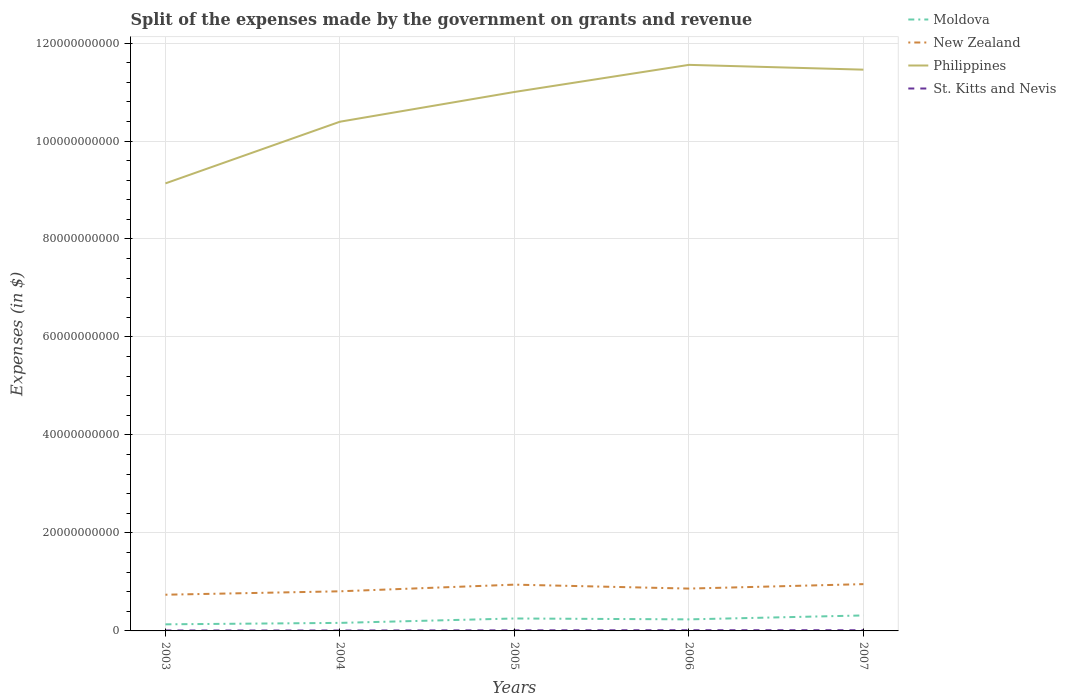How many different coloured lines are there?
Make the answer very short. 4. Does the line corresponding to Philippines intersect with the line corresponding to New Zealand?
Offer a terse response. No. Is the number of lines equal to the number of legend labels?
Your response must be concise. Yes. Across all years, what is the maximum expenses made by the government on grants and revenue in Moldova?
Your answer should be compact. 1.35e+09. What is the total expenses made by the government on grants and revenue in St. Kitts and Nevis in the graph?
Give a very brief answer. -3.42e+07. What is the difference between the highest and the second highest expenses made by the government on grants and revenue in Moldova?
Offer a very short reply. 1.81e+09. Is the expenses made by the government on grants and revenue in St. Kitts and Nevis strictly greater than the expenses made by the government on grants and revenue in New Zealand over the years?
Ensure brevity in your answer.  Yes. How many lines are there?
Offer a terse response. 4. Are the values on the major ticks of Y-axis written in scientific E-notation?
Your answer should be compact. No. How many legend labels are there?
Keep it short and to the point. 4. What is the title of the graph?
Make the answer very short. Split of the expenses made by the government on grants and revenue. Does "Venezuela" appear as one of the legend labels in the graph?
Make the answer very short. No. What is the label or title of the X-axis?
Offer a terse response. Years. What is the label or title of the Y-axis?
Offer a very short reply. Expenses (in $). What is the Expenses (in $) of Moldova in 2003?
Keep it short and to the point. 1.35e+09. What is the Expenses (in $) in New Zealand in 2003?
Offer a terse response. 7.39e+09. What is the Expenses (in $) in Philippines in 2003?
Your response must be concise. 9.14e+1. What is the Expenses (in $) of St. Kitts and Nevis in 2003?
Your answer should be compact. 9.36e+07. What is the Expenses (in $) in Moldova in 2004?
Your answer should be compact. 1.64e+09. What is the Expenses (in $) in New Zealand in 2004?
Offer a terse response. 8.09e+09. What is the Expenses (in $) of Philippines in 2004?
Ensure brevity in your answer.  1.04e+11. What is the Expenses (in $) of St. Kitts and Nevis in 2004?
Ensure brevity in your answer.  8.76e+07. What is the Expenses (in $) in Moldova in 2005?
Keep it short and to the point. 2.54e+09. What is the Expenses (in $) in New Zealand in 2005?
Give a very brief answer. 9.45e+09. What is the Expenses (in $) in Philippines in 2005?
Make the answer very short. 1.10e+11. What is the Expenses (in $) in St. Kitts and Nevis in 2005?
Your answer should be very brief. 1.22e+08. What is the Expenses (in $) in Moldova in 2006?
Offer a very short reply. 2.36e+09. What is the Expenses (in $) in New Zealand in 2006?
Keep it short and to the point. 8.64e+09. What is the Expenses (in $) of Philippines in 2006?
Offer a terse response. 1.16e+11. What is the Expenses (in $) of St. Kitts and Nevis in 2006?
Provide a succinct answer. 1.44e+08. What is the Expenses (in $) in Moldova in 2007?
Your answer should be very brief. 3.16e+09. What is the Expenses (in $) of New Zealand in 2007?
Offer a very short reply. 9.55e+09. What is the Expenses (in $) of Philippines in 2007?
Your response must be concise. 1.15e+11. What is the Expenses (in $) in St. Kitts and Nevis in 2007?
Make the answer very short. 1.45e+08. Across all years, what is the maximum Expenses (in $) in Moldova?
Your response must be concise. 3.16e+09. Across all years, what is the maximum Expenses (in $) in New Zealand?
Your answer should be compact. 9.55e+09. Across all years, what is the maximum Expenses (in $) of Philippines?
Keep it short and to the point. 1.16e+11. Across all years, what is the maximum Expenses (in $) of St. Kitts and Nevis?
Keep it short and to the point. 1.45e+08. Across all years, what is the minimum Expenses (in $) of Moldova?
Ensure brevity in your answer.  1.35e+09. Across all years, what is the minimum Expenses (in $) in New Zealand?
Provide a succinct answer. 7.39e+09. Across all years, what is the minimum Expenses (in $) in Philippines?
Your answer should be very brief. 9.14e+1. Across all years, what is the minimum Expenses (in $) in St. Kitts and Nevis?
Ensure brevity in your answer.  8.76e+07. What is the total Expenses (in $) of Moldova in the graph?
Offer a very short reply. 1.10e+1. What is the total Expenses (in $) in New Zealand in the graph?
Offer a terse response. 4.31e+1. What is the total Expenses (in $) in Philippines in the graph?
Your answer should be compact. 5.35e+11. What is the total Expenses (in $) of St. Kitts and Nevis in the graph?
Your answer should be compact. 5.92e+08. What is the difference between the Expenses (in $) of Moldova in 2003 and that in 2004?
Offer a terse response. -2.94e+08. What is the difference between the Expenses (in $) in New Zealand in 2003 and that in 2004?
Your answer should be compact. -6.97e+08. What is the difference between the Expenses (in $) of Philippines in 2003 and that in 2004?
Keep it short and to the point. -1.26e+1. What is the difference between the Expenses (in $) in St. Kitts and Nevis in 2003 and that in 2004?
Provide a succinct answer. 6.00e+06. What is the difference between the Expenses (in $) in Moldova in 2003 and that in 2005?
Offer a terse response. -1.19e+09. What is the difference between the Expenses (in $) in New Zealand in 2003 and that in 2005?
Your answer should be compact. -2.06e+09. What is the difference between the Expenses (in $) in Philippines in 2003 and that in 2005?
Keep it short and to the point. -1.87e+1. What is the difference between the Expenses (in $) of St. Kitts and Nevis in 2003 and that in 2005?
Your response must be concise. -2.82e+07. What is the difference between the Expenses (in $) of Moldova in 2003 and that in 2006?
Offer a terse response. -1.01e+09. What is the difference between the Expenses (in $) of New Zealand in 2003 and that in 2006?
Provide a succinct answer. -1.25e+09. What is the difference between the Expenses (in $) of Philippines in 2003 and that in 2006?
Provide a succinct answer. -2.42e+1. What is the difference between the Expenses (in $) of St. Kitts and Nevis in 2003 and that in 2006?
Ensure brevity in your answer.  -5.08e+07. What is the difference between the Expenses (in $) of Moldova in 2003 and that in 2007?
Your answer should be compact. -1.81e+09. What is the difference between the Expenses (in $) in New Zealand in 2003 and that in 2007?
Make the answer very short. -2.16e+09. What is the difference between the Expenses (in $) in Philippines in 2003 and that in 2007?
Keep it short and to the point. -2.32e+1. What is the difference between the Expenses (in $) of St. Kitts and Nevis in 2003 and that in 2007?
Give a very brief answer. -5.14e+07. What is the difference between the Expenses (in $) of Moldova in 2004 and that in 2005?
Make the answer very short. -9.00e+08. What is the difference between the Expenses (in $) of New Zealand in 2004 and that in 2005?
Make the answer very short. -1.36e+09. What is the difference between the Expenses (in $) of Philippines in 2004 and that in 2005?
Make the answer very short. -6.07e+09. What is the difference between the Expenses (in $) of St. Kitts and Nevis in 2004 and that in 2005?
Keep it short and to the point. -3.42e+07. What is the difference between the Expenses (in $) in Moldova in 2004 and that in 2006?
Offer a very short reply. -7.19e+08. What is the difference between the Expenses (in $) in New Zealand in 2004 and that in 2006?
Give a very brief answer. -5.56e+08. What is the difference between the Expenses (in $) in Philippines in 2004 and that in 2006?
Ensure brevity in your answer.  -1.16e+1. What is the difference between the Expenses (in $) in St. Kitts and Nevis in 2004 and that in 2006?
Your response must be concise. -5.68e+07. What is the difference between the Expenses (in $) in Moldova in 2004 and that in 2007?
Provide a short and direct response. -1.52e+09. What is the difference between the Expenses (in $) in New Zealand in 2004 and that in 2007?
Offer a terse response. -1.46e+09. What is the difference between the Expenses (in $) in Philippines in 2004 and that in 2007?
Offer a very short reply. -1.06e+1. What is the difference between the Expenses (in $) of St. Kitts and Nevis in 2004 and that in 2007?
Your response must be concise. -5.74e+07. What is the difference between the Expenses (in $) of Moldova in 2005 and that in 2006?
Your answer should be very brief. 1.80e+08. What is the difference between the Expenses (in $) in New Zealand in 2005 and that in 2006?
Give a very brief answer. 8.05e+08. What is the difference between the Expenses (in $) of Philippines in 2005 and that in 2006?
Make the answer very short. -5.54e+09. What is the difference between the Expenses (in $) in St. Kitts and Nevis in 2005 and that in 2006?
Give a very brief answer. -2.26e+07. What is the difference between the Expenses (in $) in Moldova in 2005 and that in 2007?
Ensure brevity in your answer.  -6.21e+08. What is the difference between the Expenses (in $) of New Zealand in 2005 and that in 2007?
Make the answer very short. -1.03e+08. What is the difference between the Expenses (in $) of Philippines in 2005 and that in 2007?
Provide a succinct answer. -4.56e+09. What is the difference between the Expenses (in $) of St. Kitts and Nevis in 2005 and that in 2007?
Your answer should be compact. -2.32e+07. What is the difference between the Expenses (in $) in Moldova in 2006 and that in 2007?
Offer a terse response. -8.02e+08. What is the difference between the Expenses (in $) in New Zealand in 2006 and that in 2007?
Offer a very short reply. -9.08e+08. What is the difference between the Expenses (in $) of Philippines in 2006 and that in 2007?
Offer a very short reply. 9.80e+08. What is the difference between the Expenses (in $) in St. Kitts and Nevis in 2006 and that in 2007?
Your answer should be compact. -6.00e+05. What is the difference between the Expenses (in $) in Moldova in 2003 and the Expenses (in $) in New Zealand in 2004?
Ensure brevity in your answer.  -6.74e+09. What is the difference between the Expenses (in $) of Moldova in 2003 and the Expenses (in $) of Philippines in 2004?
Offer a terse response. -1.03e+11. What is the difference between the Expenses (in $) of Moldova in 2003 and the Expenses (in $) of St. Kitts and Nevis in 2004?
Your answer should be very brief. 1.26e+09. What is the difference between the Expenses (in $) in New Zealand in 2003 and the Expenses (in $) in Philippines in 2004?
Provide a succinct answer. -9.65e+1. What is the difference between the Expenses (in $) in New Zealand in 2003 and the Expenses (in $) in St. Kitts and Nevis in 2004?
Provide a succinct answer. 7.30e+09. What is the difference between the Expenses (in $) in Philippines in 2003 and the Expenses (in $) in St. Kitts and Nevis in 2004?
Ensure brevity in your answer.  9.13e+1. What is the difference between the Expenses (in $) of Moldova in 2003 and the Expenses (in $) of New Zealand in 2005?
Provide a succinct answer. -8.10e+09. What is the difference between the Expenses (in $) of Moldova in 2003 and the Expenses (in $) of Philippines in 2005?
Give a very brief answer. -1.09e+11. What is the difference between the Expenses (in $) of Moldova in 2003 and the Expenses (in $) of St. Kitts and Nevis in 2005?
Make the answer very short. 1.22e+09. What is the difference between the Expenses (in $) of New Zealand in 2003 and the Expenses (in $) of Philippines in 2005?
Make the answer very short. -1.03e+11. What is the difference between the Expenses (in $) of New Zealand in 2003 and the Expenses (in $) of St. Kitts and Nevis in 2005?
Offer a very short reply. 7.27e+09. What is the difference between the Expenses (in $) of Philippines in 2003 and the Expenses (in $) of St. Kitts and Nevis in 2005?
Give a very brief answer. 9.12e+1. What is the difference between the Expenses (in $) of Moldova in 2003 and the Expenses (in $) of New Zealand in 2006?
Your response must be concise. -7.30e+09. What is the difference between the Expenses (in $) in Moldova in 2003 and the Expenses (in $) in Philippines in 2006?
Give a very brief answer. -1.14e+11. What is the difference between the Expenses (in $) in Moldova in 2003 and the Expenses (in $) in St. Kitts and Nevis in 2006?
Your answer should be very brief. 1.20e+09. What is the difference between the Expenses (in $) in New Zealand in 2003 and the Expenses (in $) in Philippines in 2006?
Provide a succinct answer. -1.08e+11. What is the difference between the Expenses (in $) in New Zealand in 2003 and the Expenses (in $) in St. Kitts and Nevis in 2006?
Offer a terse response. 7.25e+09. What is the difference between the Expenses (in $) in Philippines in 2003 and the Expenses (in $) in St. Kitts and Nevis in 2006?
Make the answer very short. 9.12e+1. What is the difference between the Expenses (in $) of Moldova in 2003 and the Expenses (in $) of New Zealand in 2007?
Make the answer very short. -8.20e+09. What is the difference between the Expenses (in $) in Moldova in 2003 and the Expenses (in $) in Philippines in 2007?
Offer a terse response. -1.13e+11. What is the difference between the Expenses (in $) of Moldova in 2003 and the Expenses (in $) of St. Kitts and Nevis in 2007?
Make the answer very short. 1.20e+09. What is the difference between the Expenses (in $) in New Zealand in 2003 and the Expenses (in $) in Philippines in 2007?
Offer a very short reply. -1.07e+11. What is the difference between the Expenses (in $) in New Zealand in 2003 and the Expenses (in $) in St. Kitts and Nevis in 2007?
Your response must be concise. 7.25e+09. What is the difference between the Expenses (in $) of Philippines in 2003 and the Expenses (in $) of St. Kitts and Nevis in 2007?
Your answer should be compact. 9.12e+1. What is the difference between the Expenses (in $) of Moldova in 2004 and the Expenses (in $) of New Zealand in 2005?
Provide a succinct answer. -7.81e+09. What is the difference between the Expenses (in $) of Moldova in 2004 and the Expenses (in $) of Philippines in 2005?
Your answer should be very brief. -1.08e+11. What is the difference between the Expenses (in $) in Moldova in 2004 and the Expenses (in $) in St. Kitts and Nevis in 2005?
Make the answer very short. 1.52e+09. What is the difference between the Expenses (in $) of New Zealand in 2004 and the Expenses (in $) of Philippines in 2005?
Keep it short and to the point. -1.02e+11. What is the difference between the Expenses (in $) in New Zealand in 2004 and the Expenses (in $) in St. Kitts and Nevis in 2005?
Your answer should be very brief. 7.97e+09. What is the difference between the Expenses (in $) in Philippines in 2004 and the Expenses (in $) in St. Kitts and Nevis in 2005?
Offer a very short reply. 1.04e+11. What is the difference between the Expenses (in $) of Moldova in 2004 and the Expenses (in $) of New Zealand in 2006?
Provide a short and direct response. -7.00e+09. What is the difference between the Expenses (in $) of Moldova in 2004 and the Expenses (in $) of Philippines in 2006?
Keep it short and to the point. -1.14e+11. What is the difference between the Expenses (in $) of Moldova in 2004 and the Expenses (in $) of St. Kitts and Nevis in 2006?
Offer a terse response. 1.50e+09. What is the difference between the Expenses (in $) of New Zealand in 2004 and the Expenses (in $) of Philippines in 2006?
Make the answer very short. -1.07e+11. What is the difference between the Expenses (in $) in New Zealand in 2004 and the Expenses (in $) in St. Kitts and Nevis in 2006?
Your response must be concise. 7.94e+09. What is the difference between the Expenses (in $) in Philippines in 2004 and the Expenses (in $) in St. Kitts and Nevis in 2006?
Provide a succinct answer. 1.04e+11. What is the difference between the Expenses (in $) in Moldova in 2004 and the Expenses (in $) in New Zealand in 2007?
Offer a very short reply. -7.91e+09. What is the difference between the Expenses (in $) in Moldova in 2004 and the Expenses (in $) in Philippines in 2007?
Your response must be concise. -1.13e+11. What is the difference between the Expenses (in $) in Moldova in 2004 and the Expenses (in $) in St. Kitts and Nevis in 2007?
Your response must be concise. 1.49e+09. What is the difference between the Expenses (in $) of New Zealand in 2004 and the Expenses (in $) of Philippines in 2007?
Your answer should be compact. -1.06e+11. What is the difference between the Expenses (in $) of New Zealand in 2004 and the Expenses (in $) of St. Kitts and Nevis in 2007?
Ensure brevity in your answer.  7.94e+09. What is the difference between the Expenses (in $) of Philippines in 2004 and the Expenses (in $) of St. Kitts and Nevis in 2007?
Provide a succinct answer. 1.04e+11. What is the difference between the Expenses (in $) of Moldova in 2005 and the Expenses (in $) of New Zealand in 2006?
Offer a terse response. -6.10e+09. What is the difference between the Expenses (in $) of Moldova in 2005 and the Expenses (in $) of Philippines in 2006?
Give a very brief answer. -1.13e+11. What is the difference between the Expenses (in $) in Moldova in 2005 and the Expenses (in $) in St. Kitts and Nevis in 2006?
Your answer should be compact. 2.39e+09. What is the difference between the Expenses (in $) in New Zealand in 2005 and the Expenses (in $) in Philippines in 2006?
Your answer should be very brief. -1.06e+11. What is the difference between the Expenses (in $) of New Zealand in 2005 and the Expenses (in $) of St. Kitts and Nevis in 2006?
Provide a succinct answer. 9.30e+09. What is the difference between the Expenses (in $) of Philippines in 2005 and the Expenses (in $) of St. Kitts and Nevis in 2006?
Offer a terse response. 1.10e+11. What is the difference between the Expenses (in $) of Moldova in 2005 and the Expenses (in $) of New Zealand in 2007?
Offer a terse response. -7.01e+09. What is the difference between the Expenses (in $) in Moldova in 2005 and the Expenses (in $) in Philippines in 2007?
Your response must be concise. -1.12e+11. What is the difference between the Expenses (in $) of Moldova in 2005 and the Expenses (in $) of St. Kitts and Nevis in 2007?
Provide a short and direct response. 2.39e+09. What is the difference between the Expenses (in $) in New Zealand in 2005 and the Expenses (in $) in Philippines in 2007?
Provide a short and direct response. -1.05e+11. What is the difference between the Expenses (in $) in New Zealand in 2005 and the Expenses (in $) in St. Kitts and Nevis in 2007?
Provide a short and direct response. 9.30e+09. What is the difference between the Expenses (in $) in Philippines in 2005 and the Expenses (in $) in St. Kitts and Nevis in 2007?
Provide a succinct answer. 1.10e+11. What is the difference between the Expenses (in $) of Moldova in 2006 and the Expenses (in $) of New Zealand in 2007?
Your answer should be very brief. -7.19e+09. What is the difference between the Expenses (in $) in Moldova in 2006 and the Expenses (in $) in Philippines in 2007?
Offer a terse response. -1.12e+11. What is the difference between the Expenses (in $) of Moldova in 2006 and the Expenses (in $) of St. Kitts and Nevis in 2007?
Make the answer very short. 2.21e+09. What is the difference between the Expenses (in $) in New Zealand in 2006 and the Expenses (in $) in Philippines in 2007?
Ensure brevity in your answer.  -1.06e+11. What is the difference between the Expenses (in $) in New Zealand in 2006 and the Expenses (in $) in St. Kitts and Nevis in 2007?
Your answer should be very brief. 8.50e+09. What is the difference between the Expenses (in $) of Philippines in 2006 and the Expenses (in $) of St. Kitts and Nevis in 2007?
Give a very brief answer. 1.15e+11. What is the average Expenses (in $) of Moldova per year?
Make the answer very short. 2.21e+09. What is the average Expenses (in $) in New Zealand per year?
Your answer should be very brief. 8.62e+09. What is the average Expenses (in $) of Philippines per year?
Offer a very short reply. 1.07e+11. What is the average Expenses (in $) in St. Kitts and Nevis per year?
Make the answer very short. 1.18e+08. In the year 2003, what is the difference between the Expenses (in $) of Moldova and Expenses (in $) of New Zealand?
Make the answer very short. -6.04e+09. In the year 2003, what is the difference between the Expenses (in $) in Moldova and Expenses (in $) in Philippines?
Give a very brief answer. -9.00e+1. In the year 2003, what is the difference between the Expenses (in $) of Moldova and Expenses (in $) of St. Kitts and Nevis?
Ensure brevity in your answer.  1.25e+09. In the year 2003, what is the difference between the Expenses (in $) of New Zealand and Expenses (in $) of Philippines?
Ensure brevity in your answer.  -8.40e+1. In the year 2003, what is the difference between the Expenses (in $) in New Zealand and Expenses (in $) in St. Kitts and Nevis?
Your answer should be very brief. 7.30e+09. In the year 2003, what is the difference between the Expenses (in $) in Philippines and Expenses (in $) in St. Kitts and Nevis?
Your answer should be compact. 9.13e+1. In the year 2004, what is the difference between the Expenses (in $) of Moldova and Expenses (in $) of New Zealand?
Provide a succinct answer. -6.45e+09. In the year 2004, what is the difference between the Expenses (in $) of Moldova and Expenses (in $) of Philippines?
Keep it short and to the point. -1.02e+11. In the year 2004, what is the difference between the Expenses (in $) in Moldova and Expenses (in $) in St. Kitts and Nevis?
Ensure brevity in your answer.  1.55e+09. In the year 2004, what is the difference between the Expenses (in $) in New Zealand and Expenses (in $) in Philippines?
Your answer should be compact. -9.59e+1. In the year 2004, what is the difference between the Expenses (in $) in New Zealand and Expenses (in $) in St. Kitts and Nevis?
Offer a very short reply. 8.00e+09. In the year 2004, what is the difference between the Expenses (in $) in Philippines and Expenses (in $) in St. Kitts and Nevis?
Your answer should be very brief. 1.04e+11. In the year 2005, what is the difference between the Expenses (in $) in Moldova and Expenses (in $) in New Zealand?
Ensure brevity in your answer.  -6.91e+09. In the year 2005, what is the difference between the Expenses (in $) in Moldova and Expenses (in $) in Philippines?
Offer a very short reply. -1.07e+11. In the year 2005, what is the difference between the Expenses (in $) of Moldova and Expenses (in $) of St. Kitts and Nevis?
Offer a terse response. 2.42e+09. In the year 2005, what is the difference between the Expenses (in $) in New Zealand and Expenses (in $) in Philippines?
Your response must be concise. -1.01e+11. In the year 2005, what is the difference between the Expenses (in $) of New Zealand and Expenses (in $) of St. Kitts and Nevis?
Offer a terse response. 9.33e+09. In the year 2005, what is the difference between the Expenses (in $) of Philippines and Expenses (in $) of St. Kitts and Nevis?
Keep it short and to the point. 1.10e+11. In the year 2006, what is the difference between the Expenses (in $) in Moldova and Expenses (in $) in New Zealand?
Offer a terse response. -6.28e+09. In the year 2006, what is the difference between the Expenses (in $) in Moldova and Expenses (in $) in Philippines?
Offer a very short reply. -1.13e+11. In the year 2006, what is the difference between the Expenses (in $) of Moldova and Expenses (in $) of St. Kitts and Nevis?
Your answer should be very brief. 2.21e+09. In the year 2006, what is the difference between the Expenses (in $) in New Zealand and Expenses (in $) in Philippines?
Ensure brevity in your answer.  -1.07e+11. In the year 2006, what is the difference between the Expenses (in $) of New Zealand and Expenses (in $) of St. Kitts and Nevis?
Your answer should be very brief. 8.50e+09. In the year 2006, what is the difference between the Expenses (in $) of Philippines and Expenses (in $) of St. Kitts and Nevis?
Offer a very short reply. 1.15e+11. In the year 2007, what is the difference between the Expenses (in $) of Moldova and Expenses (in $) of New Zealand?
Ensure brevity in your answer.  -6.39e+09. In the year 2007, what is the difference between the Expenses (in $) in Moldova and Expenses (in $) in Philippines?
Give a very brief answer. -1.11e+11. In the year 2007, what is the difference between the Expenses (in $) of Moldova and Expenses (in $) of St. Kitts and Nevis?
Your response must be concise. 3.02e+09. In the year 2007, what is the difference between the Expenses (in $) in New Zealand and Expenses (in $) in Philippines?
Provide a short and direct response. -1.05e+11. In the year 2007, what is the difference between the Expenses (in $) in New Zealand and Expenses (in $) in St. Kitts and Nevis?
Offer a very short reply. 9.41e+09. In the year 2007, what is the difference between the Expenses (in $) in Philippines and Expenses (in $) in St. Kitts and Nevis?
Your answer should be very brief. 1.14e+11. What is the ratio of the Expenses (in $) in Moldova in 2003 to that in 2004?
Provide a short and direct response. 0.82. What is the ratio of the Expenses (in $) of New Zealand in 2003 to that in 2004?
Make the answer very short. 0.91. What is the ratio of the Expenses (in $) of Philippines in 2003 to that in 2004?
Your response must be concise. 0.88. What is the ratio of the Expenses (in $) in St. Kitts and Nevis in 2003 to that in 2004?
Your response must be concise. 1.07. What is the ratio of the Expenses (in $) of Moldova in 2003 to that in 2005?
Offer a very short reply. 0.53. What is the ratio of the Expenses (in $) in New Zealand in 2003 to that in 2005?
Give a very brief answer. 0.78. What is the ratio of the Expenses (in $) in Philippines in 2003 to that in 2005?
Provide a succinct answer. 0.83. What is the ratio of the Expenses (in $) of St. Kitts and Nevis in 2003 to that in 2005?
Offer a very short reply. 0.77. What is the ratio of the Expenses (in $) in Moldova in 2003 to that in 2006?
Give a very brief answer. 0.57. What is the ratio of the Expenses (in $) in New Zealand in 2003 to that in 2006?
Make the answer very short. 0.86. What is the ratio of the Expenses (in $) in Philippines in 2003 to that in 2006?
Make the answer very short. 0.79. What is the ratio of the Expenses (in $) of St. Kitts and Nevis in 2003 to that in 2006?
Make the answer very short. 0.65. What is the ratio of the Expenses (in $) of Moldova in 2003 to that in 2007?
Give a very brief answer. 0.43. What is the ratio of the Expenses (in $) in New Zealand in 2003 to that in 2007?
Provide a short and direct response. 0.77. What is the ratio of the Expenses (in $) of Philippines in 2003 to that in 2007?
Keep it short and to the point. 0.8. What is the ratio of the Expenses (in $) of St. Kitts and Nevis in 2003 to that in 2007?
Your answer should be very brief. 0.65. What is the ratio of the Expenses (in $) in Moldova in 2004 to that in 2005?
Your answer should be compact. 0.65. What is the ratio of the Expenses (in $) of New Zealand in 2004 to that in 2005?
Your answer should be compact. 0.86. What is the ratio of the Expenses (in $) in Philippines in 2004 to that in 2005?
Offer a very short reply. 0.94. What is the ratio of the Expenses (in $) in St. Kitts and Nevis in 2004 to that in 2005?
Provide a succinct answer. 0.72. What is the ratio of the Expenses (in $) of Moldova in 2004 to that in 2006?
Provide a short and direct response. 0.7. What is the ratio of the Expenses (in $) of New Zealand in 2004 to that in 2006?
Make the answer very short. 0.94. What is the ratio of the Expenses (in $) in Philippines in 2004 to that in 2006?
Provide a succinct answer. 0.9. What is the ratio of the Expenses (in $) of St. Kitts and Nevis in 2004 to that in 2006?
Provide a short and direct response. 0.61. What is the ratio of the Expenses (in $) of Moldova in 2004 to that in 2007?
Your response must be concise. 0.52. What is the ratio of the Expenses (in $) of New Zealand in 2004 to that in 2007?
Provide a short and direct response. 0.85. What is the ratio of the Expenses (in $) in Philippines in 2004 to that in 2007?
Give a very brief answer. 0.91. What is the ratio of the Expenses (in $) in St. Kitts and Nevis in 2004 to that in 2007?
Offer a terse response. 0.6. What is the ratio of the Expenses (in $) of Moldova in 2005 to that in 2006?
Your response must be concise. 1.08. What is the ratio of the Expenses (in $) of New Zealand in 2005 to that in 2006?
Your response must be concise. 1.09. What is the ratio of the Expenses (in $) in Philippines in 2005 to that in 2006?
Make the answer very short. 0.95. What is the ratio of the Expenses (in $) of St. Kitts and Nevis in 2005 to that in 2006?
Ensure brevity in your answer.  0.84. What is the ratio of the Expenses (in $) of Moldova in 2005 to that in 2007?
Your response must be concise. 0.8. What is the ratio of the Expenses (in $) of Philippines in 2005 to that in 2007?
Give a very brief answer. 0.96. What is the ratio of the Expenses (in $) in St. Kitts and Nevis in 2005 to that in 2007?
Provide a succinct answer. 0.84. What is the ratio of the Expenses (in $) in Moldova in 2006 to that in 2007?
Keep it short and to the point. 0.75. What is the ratio of the Expenses (in $) of New Zealand in 2006 to that in 2007?
Give a very brief answer. 0.9. What is the ratio of the Expenses (in $) in Philippines in 2006 to that in 2007?
Provide a short and direct response. 1.01. What is the ratio of the Expenses (in $) of St. Kitts and Nevis in 2006 to that in 2007?
Your answer should be compact. 1. What is the difference between the highest and the second highest Expenses (in $) in Moldova?
Provide a succinct answer. 6.21e+08. What is the difference between the highest and the second highest Expenses (in $) in New Zealand?
Your answer should be very brief. 1.03e+08. What is the difference between the highest and the second highest Expenses (in $) in Philippines?
Your response must be concise. 9.80e+08. What is the difference between the highest and the lowest Expenses (in $) of Moldova?
Offer a very short reply. 1.81e+09. What is the difference between the highest and the lowest Expenses (in $) in New Zealand?
Your answer should be very brief. 2.16e+09. What is the difference between the highest and the lowest Expenses (in $) of Philippines?
Ensure brevity in your answer.  2.42e+1. What is the difference between the highest and the lowest Expenses (in $) of St. Kitts and Nevis?
Provide a short and direct response. 5.74e+07. 